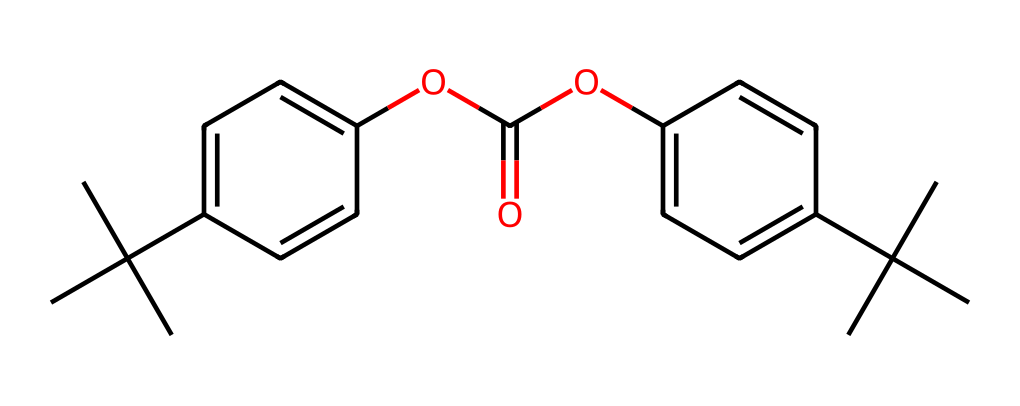What is the main functional group present in this compound? The compound features an ester functional group, indicated by the -C(=O)O- arrangement in the structure, which is typical in polycarbonates and correlates with the properties of shatter-resistant eyewear.
Answer: ester How many aromatic rings are present in this structure? By analyzing the chemical, it becomes clear that there are two aromatic rings (both are indicated by the presence of alternating double bonds). Each ring is noticeable as a distinct cyclic structure in the SMILES notation.
Answer: 2 What type of polymer does this SMILES represent? The provided SMILES represents a type of polymer known as polycarbonate, as indicated by the repeating unit containing carbonate linkages, which is characteristic of this class of materials used in eyewear for its strength and impact resistance.
Answer: polycarbonate How many carbon atoms are in this molecule? A detailed count of the carbon atoms from the structural representation indicates that there are 24 carbon atoms (14 in the isopropyl groups and 10 in the aromatic rings and other linkages) when we systematically identify each component in the structure.
Answer: 24 What role do the isopropyl groups play in the properties of this chemical? The isopropyl groups (CC(C)(C)) provide additional steric bulk and enhance the impact resistance and optical clarity of the polycarbonate, making it more suitable for shatter-resistant applications such as eyewear.
Answer: impact resistance What does the presence of the ether linkage suggest about this material? The ether linkage noted in the structure indicates potential flexibility and chemical stability, which are significant in contributing to the overall durability and robustness of the polycarbonate utilized in shatter-resistant eyewear.
Answer: flexibility and stability 